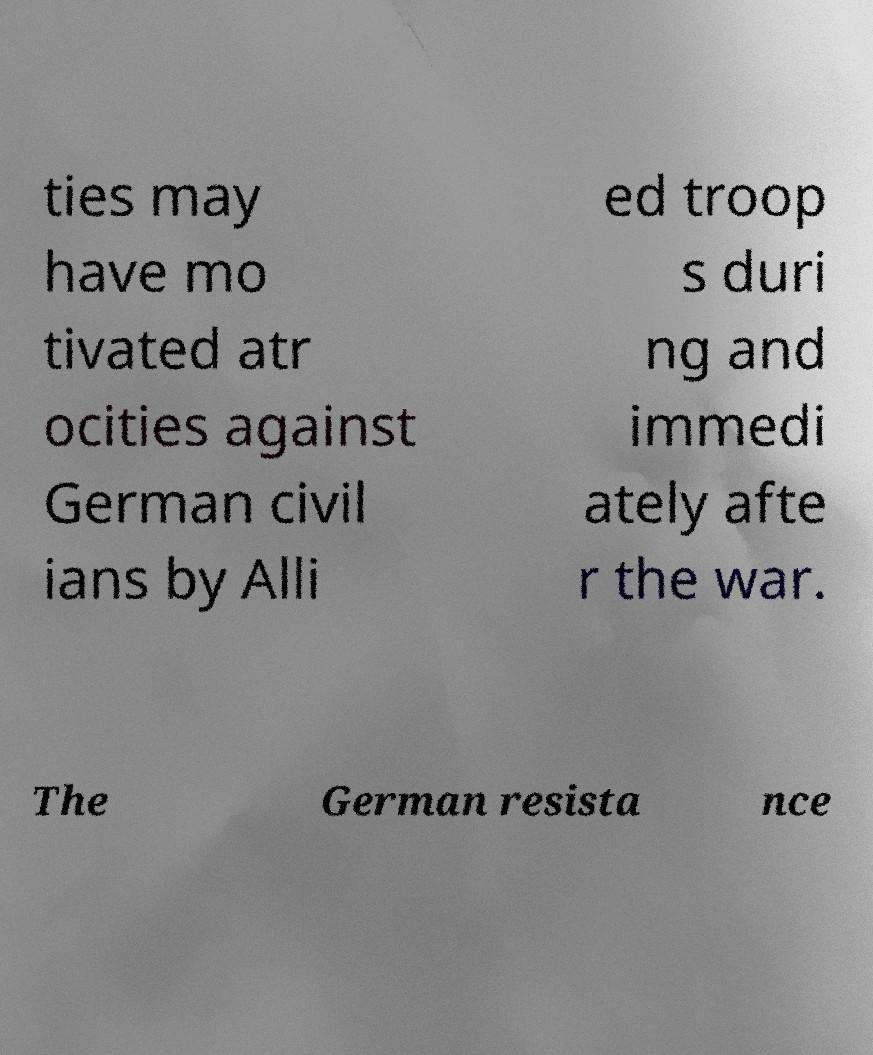Could you assist in decoding the text presented in this image and type it out clearly? ties may have mo tivated atr ocities against German civil ians by Alli ed troop s duri ng and immedi ately afte r the war. The German resista nce 